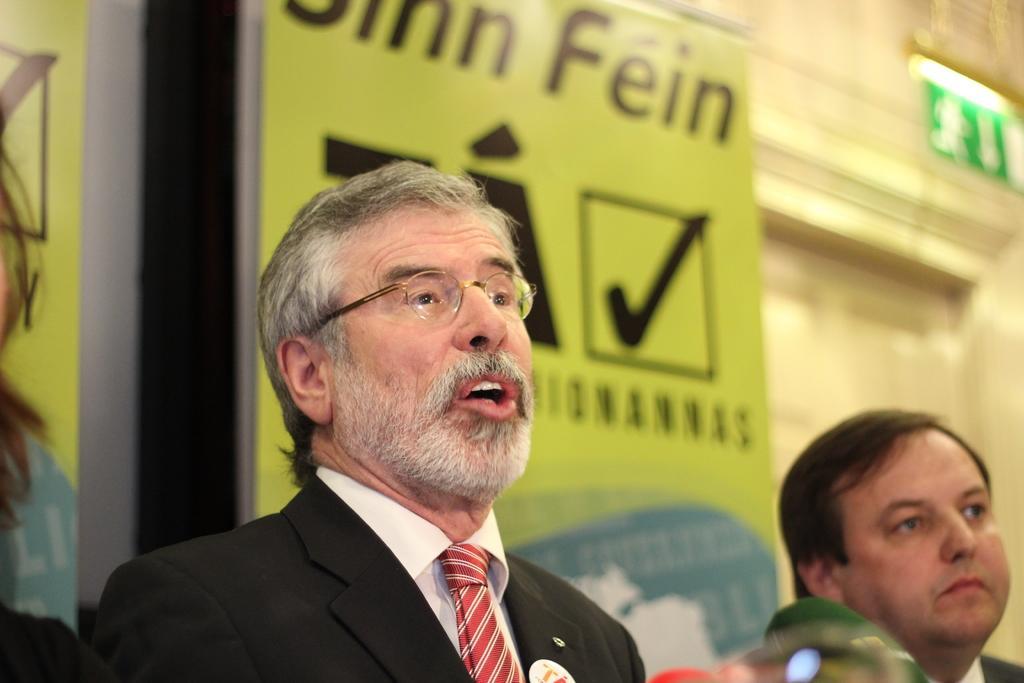How would you summarize this image in a sentence or two? In this image we can see few people. There are few advertising boards in the image. There is a door at the right side of the image. 